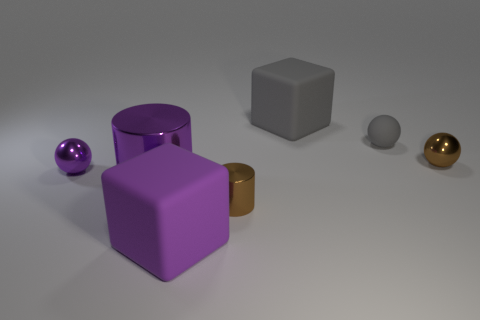Are there fewer small purple shiny things behind the purple shiny sphere than small objects in front of the large purple metallic cylinder?
Make the answer very short. Yes. What color is the small rubber ball?
Provide a short and direct response. Gray. What number of matte things have the same color as the large cylinder?
Make the answer very short. 1. Are there any large metallic cylinders on the right side of the tiny purple metallic thing?
Offer a terse response. Yes. Are there the same number of tiny gray balls that are behind the large cylinder and objects that are on the right side of the tiny brown metallic ball?
Offer a very short reply. No. There is a metallic ball that is to the right of the big gray rubber cube; does it have the same size as the purple metallic thing to the left of the large metal cylinder?
Give a very brief answer. Yes. There is a big rubber object behind the large matte block in front of the brown metal thing that is to the right of the rubber sphere; what shape is it?
Your answer should be compact. Cube. Is there any other thing that has the same material as the large gray block?
Keep it short and to the point. Yes. There is another thing that is the same shape as the large metallic thing; what size is it?
Your answer should be very brief. Small. There is a big object that is both in front of the tiny brown ball and behind the large purple block; what is its color?
Provide a short and direct response. Purple. 